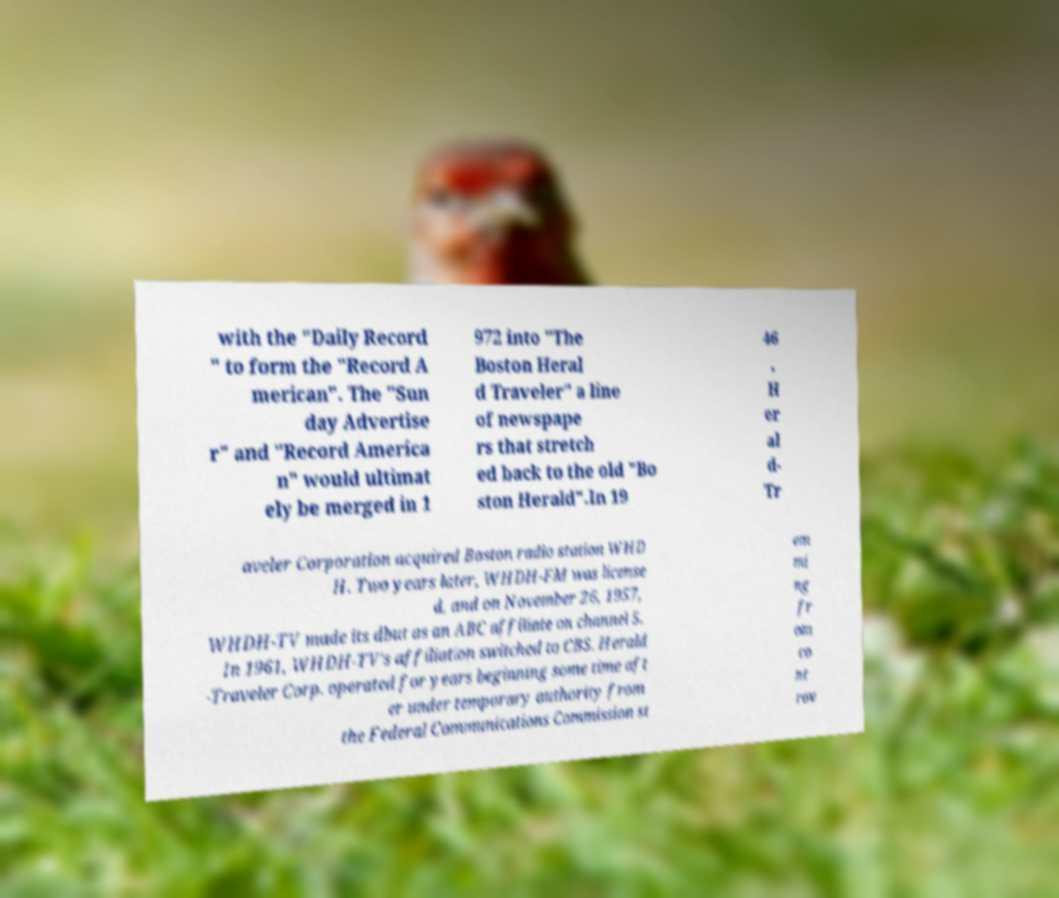Could you extract and type out the text from this image? with the "Daily Record " to form the "Record A merican". The "Sun day Advertise r" and "Record America n" would ultimat ely be merged in 1 972 into "The Boston Heral d Traveler" a line of newspape rs that stretch ed back to the old "Bo ston Herald".In 19 46 , H er al d- Tr aveler Corporation acquired Boston radio station WHD H. Two years later, WHDH-FM was license d, and on November 26, 1957, WHDH-TV made its dbut as an ABC affiliate on channel 5. In 1961, WHDH-TV's affiliation switched to CBS. Herald -Traveler Corp. operated for years beginning some time aft er under temporary authority from the Federal Communications Commission st em mi ng fr om co nt rov 